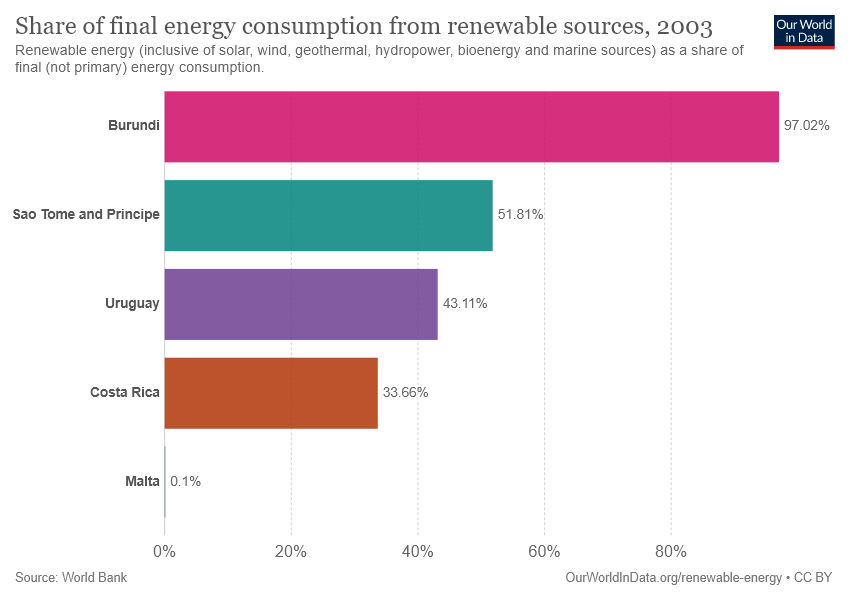Point out several critical features in this image. The ratio between Costa Rica and Uruguay is 0.7807933... Uruguay has data that shows 43.11%. 